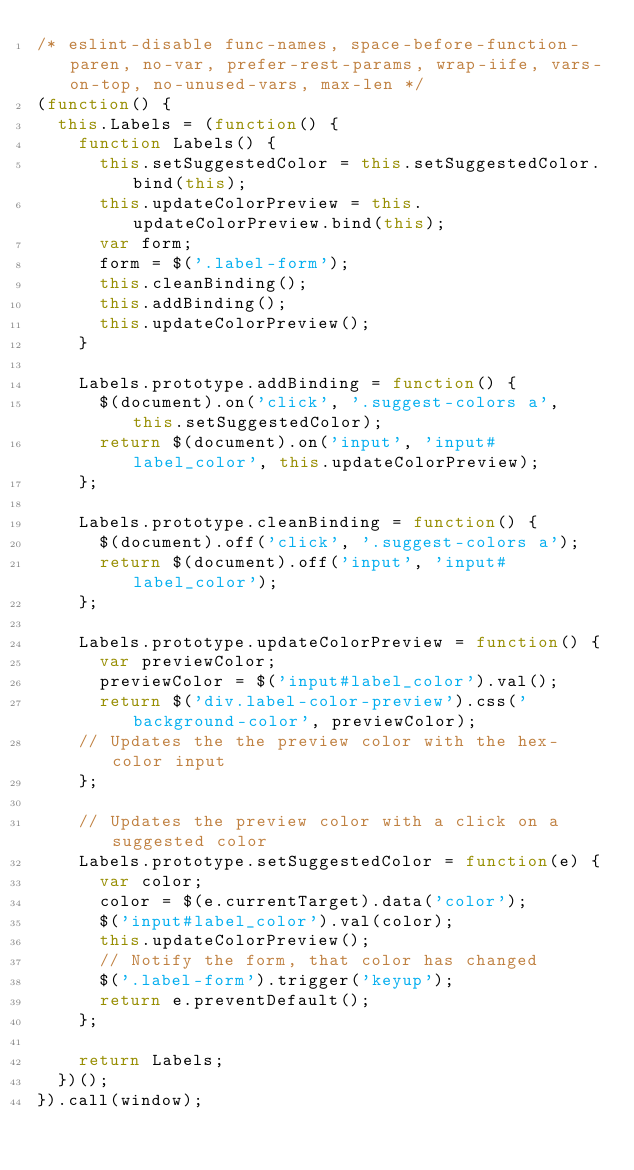<code> <loc_0><loc_0><loc_500><loc_500><_JavaScript_>/* eslint-disable func-names, space-before-function-paren, no-var, prefer-rest-params, wrap-iife, vars-on-top, no-unused-vars, max-len */
(function() {
  this.Labels = (function() {
    function Labels() {
      this.setSuggestedColor = this.setSuggestedColor.bind(this);
      this.updateColorPreview = this.updateColorPreview.bind(this);
      var form;
      form = $('.label-form');
      this.cleanBinding();
      this.addBinding();
      this.updateColorPreview();
    }

    Labels.prototype.addBinding = function() {
      $(document).on('click', '.suggest-colors a', this.setSuggestedColor);
      return $(document).on('input', 'input#label_color', this.updateColorPreview);
    };

    Labels.prototype.cleanBinding = function() {
      $(document).off('click', '.suggest-colors a');
      return $(document).off('input', 'input#label_color');
    };

    Labels.prototype.updateColorPreview = function() {
      var previewColor;
      previewColor = $('input#label_color').val();
      return $('div.label-color-preview').css('background-color', previewColor);
    // Updates the the preview color with the hex-color input
    };

    // Updates the preview color with a click on a suggested color
    Labels.prototype.setSuggestedColor = function(e) {
      var color;
      color = $(e.currentTarget).data('color');
      $('input#label_color').val(color);
      this.updateColorPreview();
      // Notify the form, that color has changed
      $('.label-form').trigger('keyup');
      return e.preventDefault();
    };

    return Labels;
  })();
}).call(window);
</code> 